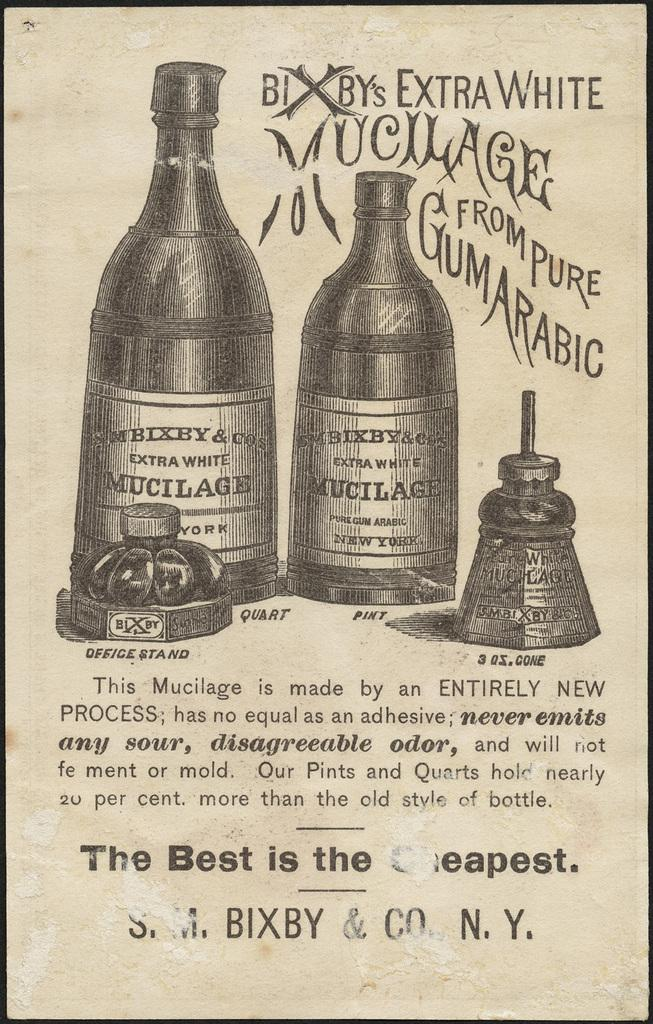<image>
Render a clear and concise summary of the photo. An ad for Bixby's extra white Mucilage from pure gumarabic 